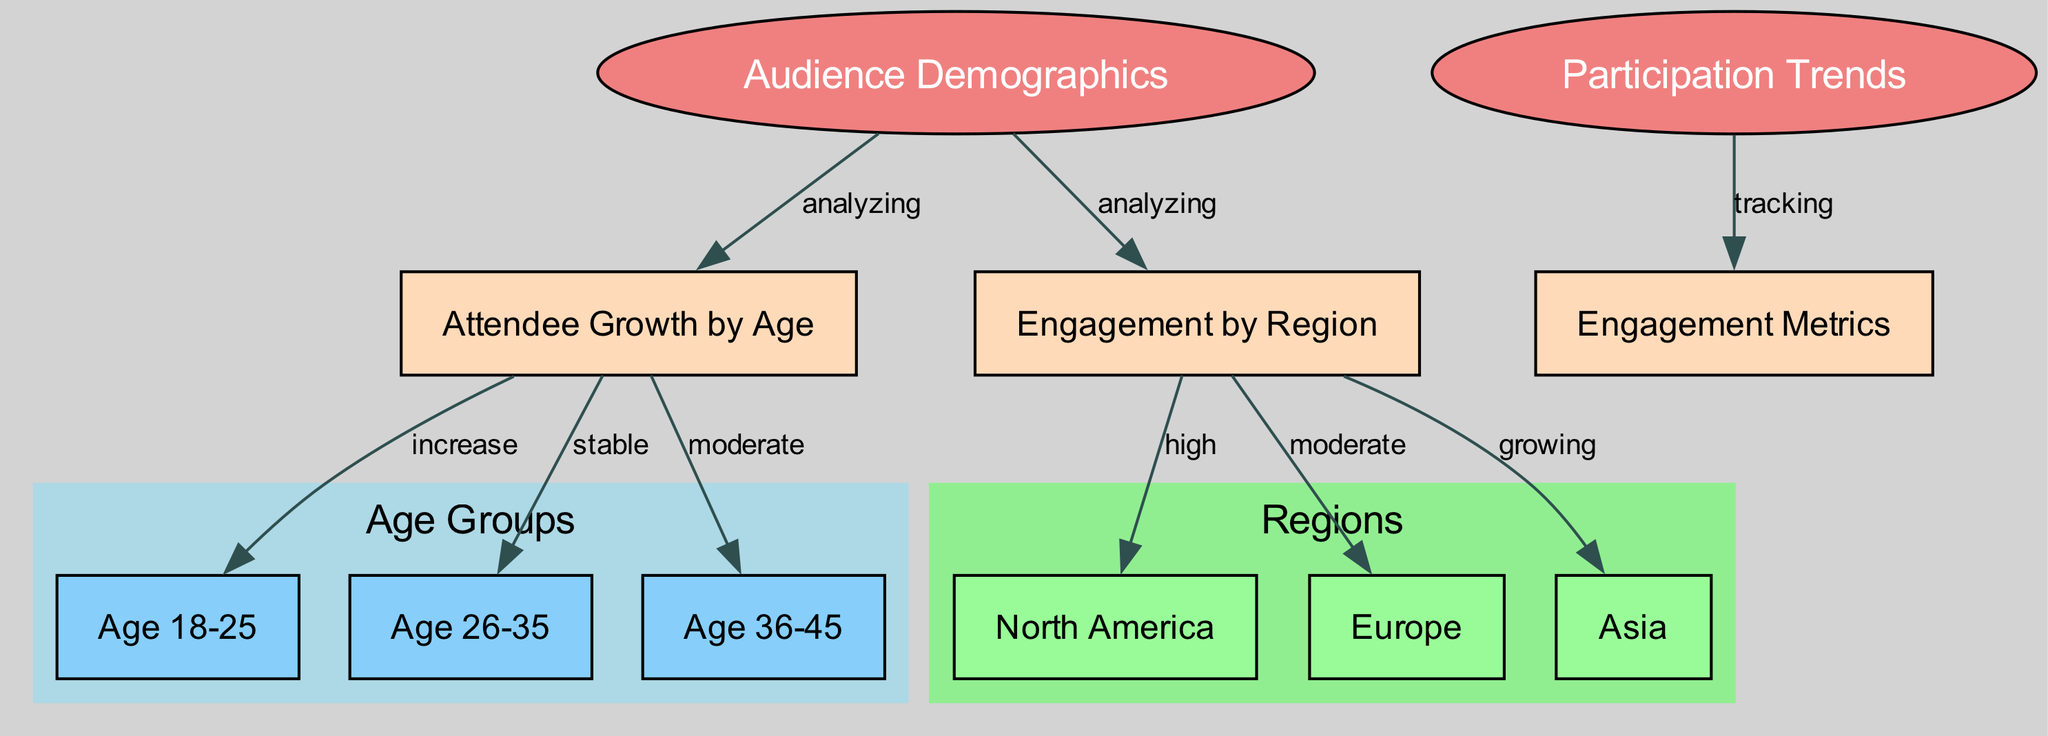What is the main focus of the diagram? The diagram's primary focus is on "Audience Demographics" and "Participation Trends" at TIFF, as indicated by the two central nodes labeled accordingly.
Answer: Audience Demographics and Participation Trends How many age groups are analyzed in the diagram? The diagram includes three specific age groups represented as nodes: Age 18-25, Age 26-35, and Age 36-45. Therefore, counting these nodes results in three distinct age groups being analyzed.
Answer: 3 What relationship exists between "Audience Demographics" and "Attendee Growth by Age"? The diagram indicates that there is an "analyzing" relationship between "Audience Demographics" and "Attendee Growth by Age," which suggests that audience demographics are studied in relation to attendee growth across various age groups.
Answer: analyzing Which region shows the highest engagement according to the diagram? The diagram states that "North America" experiences "high" engagement levels, marking it as the region with the highest engagement compared to the other regions displayed.
Answer: North America What type of engagement trend is observed in Asia? The diagram specifies that engagement in the "Asia" region is labeled as "growing." This indicates that there is a positive trend identified in terms of audience engagement metrics in that specific region.
Answer: growing Which age group has shown a stable trend in attendee growth? The diagram reveals that the age group labeled "26-35" is characterized by a "stable" trend in attendee growth, indicating consistent attendance levels among this demographic.
Answer: stable What is the connection between "Participation Trends" and "Audience Engagement Metrics"? The connection is defined by the label "tracking," indicating that participation trends at TIFF are monitored and analyzed through audience engagement metrics.
Answer: tracking Which age group shows an increase in attendance? The diagram indicates that the age group "18-25" shows an "increase" in attendance, suggesting a growing interest among this younger demographic in attending TIFF.
Answer: increase What does the "moderate" label indicate about the age group 36-45? The "moderate" label signifies that the attendee growth for the age group "36-45" is neither increasing significantly nor decreasing, suggesting a steady but not necessarily strong trend in attendance for this group.
Answer: moderate 